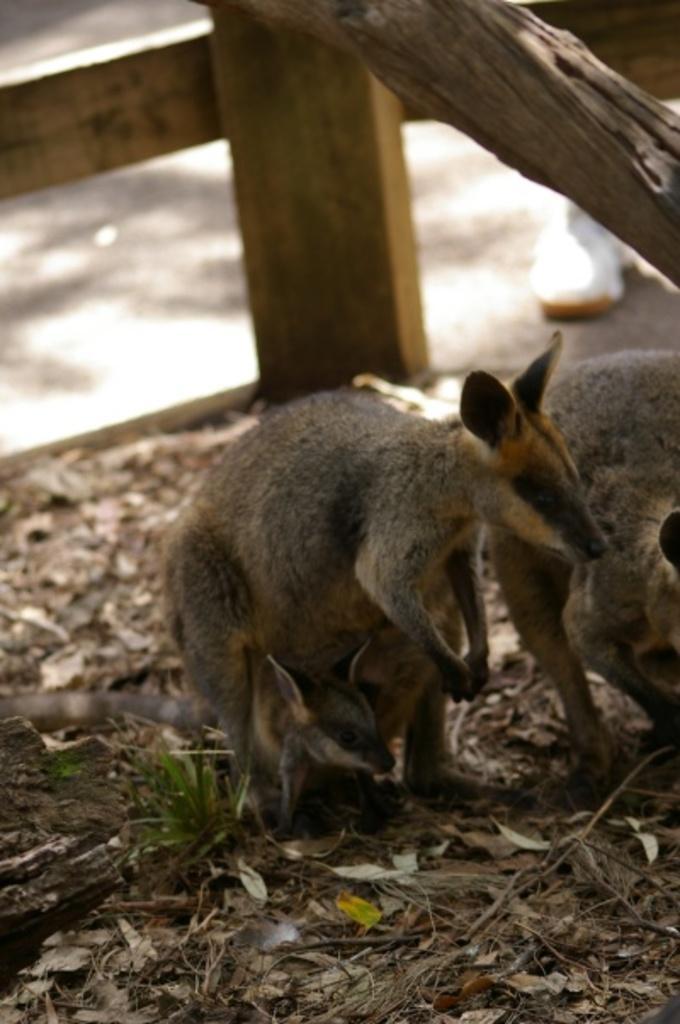Describe this image in one or two sentences. In this picture we can see animals and dried leaves on the ground, wooden objects and in the background we can see a shoe. 